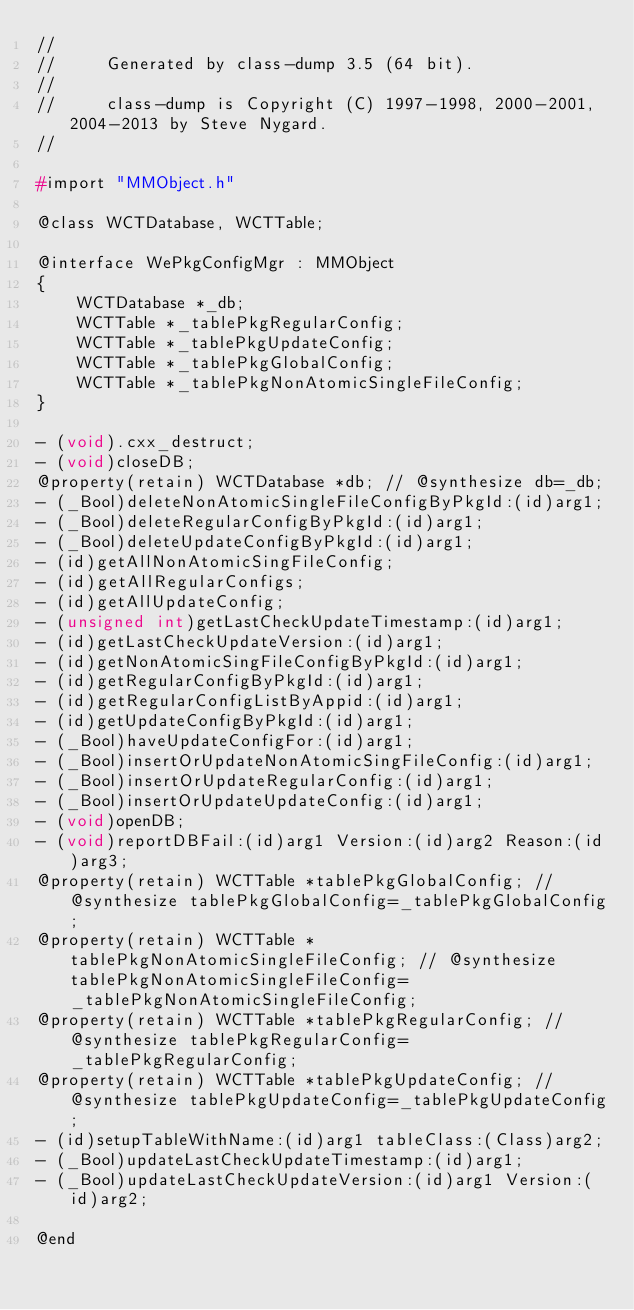<code> <loc_0><loc_0><loc_500><loc_500><_C_>//
//     Generated by class-dump 3.5 (64 bit).
//
//     class-dump is Copyright (C) 1997-1998, 2000-2001, 2004-2013 by Steve Nygard.
//

#import "MMObject.h"

@class WCTDatabase, WCTTable;

@interface WePkgConfigMgr : MMObject
{
    WCTDatabase *_db;
    WCTTable *_tablePkgRegularConfig;
    WCTTable *_tablePkgUpdateConfig;
    WCTTable *_tablePkgGlobalConfig;
    WCTTable *_tablePkgNonAtomicSingleFileConfig;
}

- (void).cxx_destruct;
- (void)closeDB;
@property(retain) WCTDatabase *db; // @synthesize db=_db;
- (_Bool)deleteNonAtomicSingleFileConfigByPkgId:(id)arg1;
- (_Bool)deleteRegularConfigByPkgId:(id)arg1;
- (_Bool)deleteUpdateConfigByPkgId:(id)arg1;
- (id)getAllNonAtomicSingFileConfig;
- (id)getAllRegularConfigs;
- (id)getAllUpdateConfig;
- (unsigned int)getLastCheckUpdateTimestamp:(id)arg1;
- (id)getLastCheckUpdateVersion:(id)arg1;
- (id)getNonAtomicSingFileConfigByPkgId:(id)arg1;
- (id)getRegularConfigByPkgId:(id)arg1;
- (id)getRegularConfigListByAppid:(id)arg1;
- (id)getUpdateConfigByPkgId:(id)arg1;
- (_Bool)haveUpdateConfigFor:(id)arg1;
- (_Bool)insertOrUpdateNonAtomicSingFileConfig:(id)arg1;
- (_Bool)insertOrUpdateRegularConfig:(id)arg1;
- (_Bool)insertOrUpdateUpdateConfig:(id)arg1;
- (void)openDB;
- (void)reportDBFail:(id)arg1 Version:(id)arg2 Reason:(id)arg3;
@property(retain) WCTTable *tablePkgGlobalConfig; // @synthesize tablePkgGlobalConfig=_tablePkgGlobalConfig;
@property(retain) WCTTable *tablePkgNonAtomicSingleFileConfig; // @synthesize tablePkgNonAtomicSingleFileConfig=_tablePkgNonAtomicSingleFileConfig;
@property(retain) WCTTable *tablePkgRegularConfig; // @synthesize tablePkgRegularConfig=_tablePkgRegularConfig;
@property(retain) WCTTable *tablePkgUpdateConfig; // @synthesize tablePkgUpdateConfig=_tablePkgUpdateConfig;
- (id)setupTableWithName:(id)arg1 tableClass:(Class)arg2;
- (_Bool)updateLastCheckUpdateTimestamp:(id)arg1;
- (_Bool)updateLastCheckUpdateVersion:(id)arg1 Version:(id)arg2;

@end

</code> 